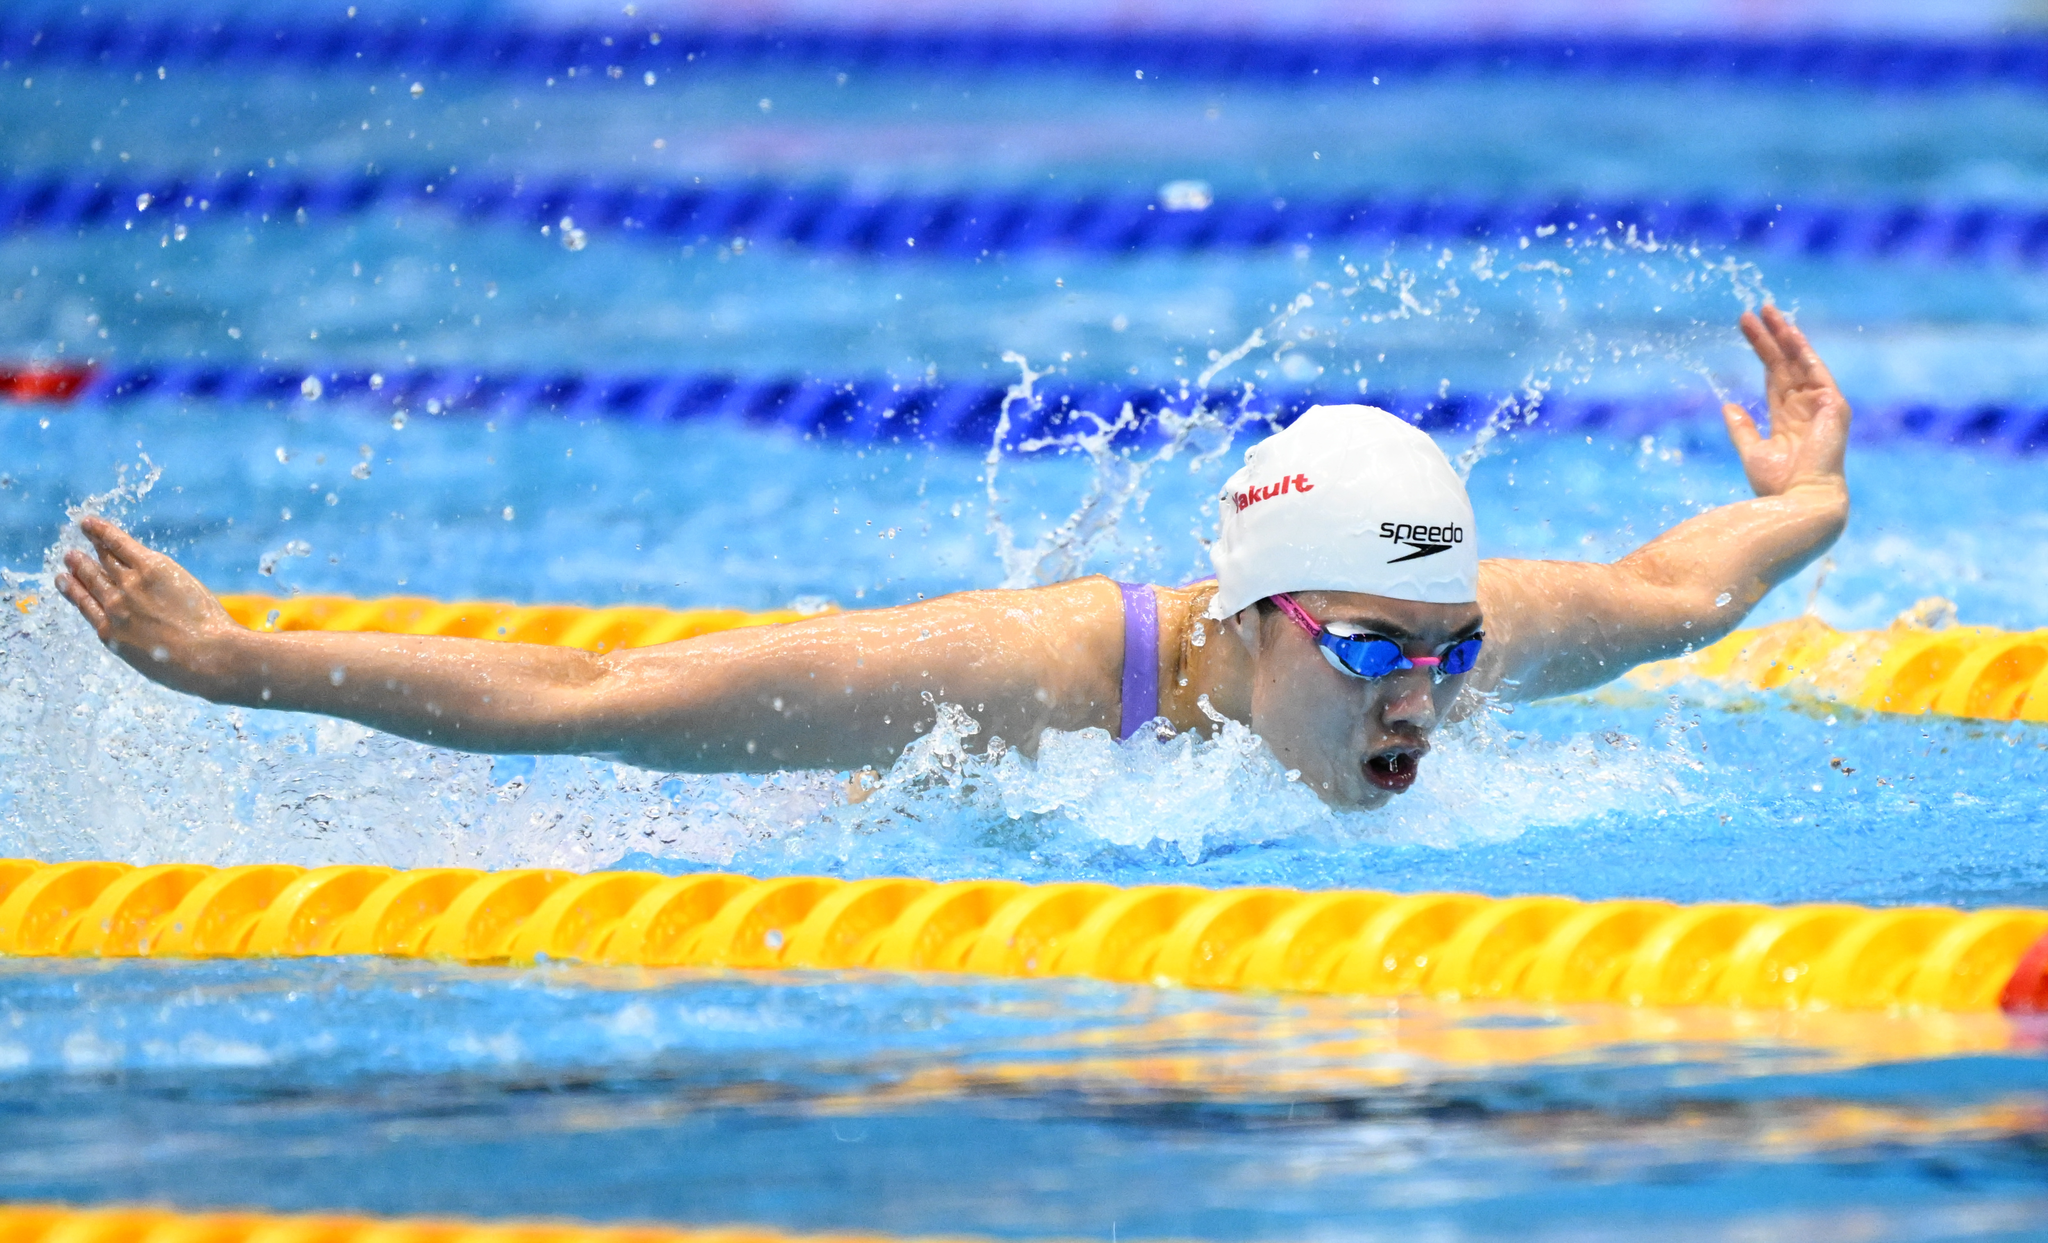What swimming style is being depicted? The swimming style being depicted is the butterfly stroke. 